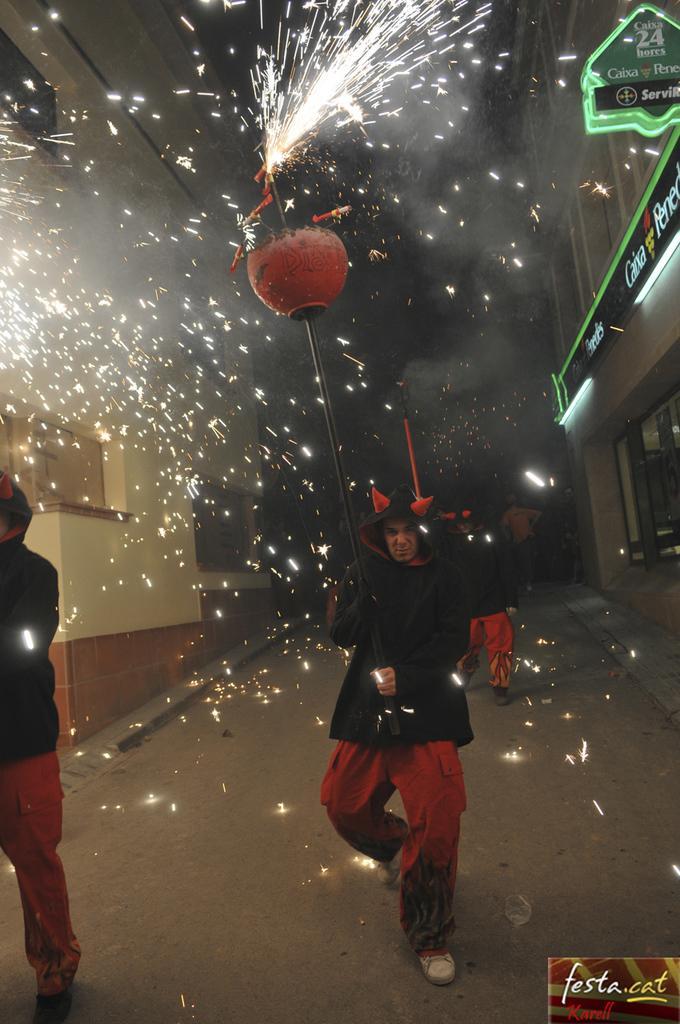Please provide a concise description of this image. This picture describes about group of people, they are walking on the road, and few people are holding metal rods, in the background we can find few houses, lights and hoardings. 